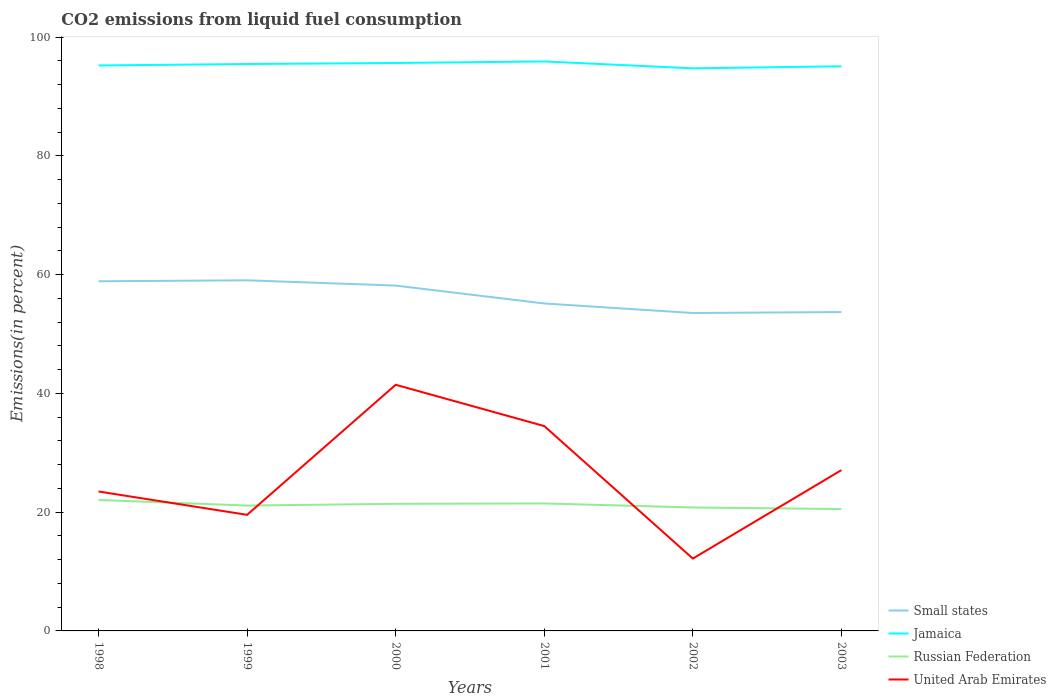How many different coloured lines are there?
Your response must be concise. 4. Does the line corresponding to United Arab Emirates intersect with the line corresponding to Small states?
Your answer should be very brief. No. Across all years, what is the maximum total CO2 emitted in United Arab Emirates?
Your answer should be very brief. 12.18. In which year was the total CO2 emitted in Russian Federation maximum?
Your response must be concise. 2003. What is the total total CO2 emitted in United Arab Emirates in the graph?
Offer a terse response. -14.95. What is the difference between the highest and the second highest total CO2 emitted in Small states?
Ensure brevity in your answer.  5.5. Is the total CO2 emitted in Small states strictly greater than the total CO2 emitted in Jamaica over the years?
Offer a very short reply. Yes. How many lines are there?
Provide a succinct answer. 4. How many years are there in the graph?
Provide a succinct answer. 6. What is the difference between two consecutive major ticks on the Y-axis?
Keep it short and to the point. 20. Does the graph contain any zero values?
Your response must be concise. No. Does the graph contain grids?
Make the answer very short. No. How many legend labels are there?
Offer a terse response. 4. What is the title of the graph?
Offer a terse response. CO2 emissions from liquid fuel consumption. Does "United Arab Emirates" appear as one of the legend labels in the graph?
Offer a very short reply. Yes. What is the label or title of the Y-axis?
Offer a terse response. Emissions(in percent). What is the Emissions(in percent) in Small states in 1998?
Make the answer very short. 58.88. What is the Emissions(in percent) of Jamaica in 1998?
Offer a very short reply. 95.21. What is the Emissions(in percent) of Russian Federation in 1998?
Offer a terse response. 22.05. What is the Emissions(in percent) of United Arab Emirates in 1998?
Make the answer very short. 23.48. What is the Emissions(in percent) of Small states in 1999?
Ensure brevity in your answer.  59.04. What is the Emissions(in percent) of Jamaica in 1999?
Offer a terse response. 95.46. What is the Emissions(in percent) in Russian Federation in 1999?
Make the answer very short. 21.11. What is the Emissions(in percent) of United Arab Emirates in 1999?
Provide a short and direct response. 19.55. What is the Emissions(in percent) of Small states in 2000?
Provide a short and direct response. 58.15. What is the Emissions(in percent) of Jamaica in 2000?
Make the answer very short. 95.63. What is the Emissions(in percent) of Russian Federation in 2000?
Offer a very short reply. 21.4. What is the Emissions(in percent) of United Arab Emirates in 2000?
Offer a terse response. 41.45. What is the Emissions(in percent) in Small states in 2001?
Your answer should be compact. 55.14. What is the Emissions(in percent) in Jamaica in 2001?
Your answer should be compact. 95.89. What is the Emissions(in percent) in Russian Federation in 2001?
Keep it short and to the point. 21.47. What is the Emissions(in percent) in United Arab Emirates in 2001?
Your answer should be very brief. 34.5. What is the Emissions(in percent) in Small states in 2002?
Provide a short and direct response. 53.53. What is the Emissions(in percent) in Jamaica in 2002?
Your answer should be compact. 94.73. What is the Emissions(in percent) in Russian Federation in 2002?
Provide a short and direct response. 20.79. What is the Emissions(in percent) in United Arab Emirates in 2002?
Keep it short and to the point. 12.18. What is the Emissions(in percent) in Small states in 2003?
Make the answer very short. 53.69. What is the Emissions(in percent) in Jamaica in 2003?
Ensure brevity in your answer.  95.08. What is the Emissions(in percent) of Russian Federation in 2003?
Offer a very short reply. 20.52. What is the Emissions(in percent) in United Arab Emirates in 2003?
Your response must be concise. 27.08. Across all years, what is the maximum Emissions(in percent) in Small states?
Make the answer very short. 59.04. Across all years, what is the maximum Emissions(in percent) in Jamaica?
Your response must be concise. 95.89. Across all years, what is the maximum Emissions(in percent) in Russian Federation?
Make the answer very short. 22.05. Across all years, what is the maximum Emissions(in percent) of United Arab Emirates?
Ensure brevity in your answer.  41.45. Across all years, what is the minimum Emissions(in percent) of Small states?
Provide a succinct answer. 53.53. Across all years, what is the minimum Emissions(in percent) of Jamaica?
Ensure brevity in your answer.  94.73. Across all years, what is the minimum Emissions(in percent) of Russian Federation?
Make the answer very short. 20.52. Across all years, what is the minimum Emissions(in percent) in United Arab Emirates?
Offer a very short reply. 12.18. What is the total Emissions(in percent) of Small states in the graph?
Your response must be concise. 338.43. What is the total Emissions(in percent) in Jamaica in the graph?
Give a very brief answer. 572. What is the total Emissions(in percent) in Russian Federation in the graph?
Offer a terse response. 127.34. What is the total Emissions(in percent) in United Arab Emirates in the graph?
Keep it short and to the point. 158.23. What is the difference between the Emissions(in percent) in Small states in 1998 and that in 1999?
Offer a terse response. -0.16. What is the difference between the Emissions(in percent) in Jamaica in 1998 and that in 1999?
Provide a short and direct response. -0.25. What is the difference between the Emissions(in percent) in Russian Federation in 1998 and that in 1999?
Your answer should be very brief. 0.94. What is the difference between the Emissions(in percent) of United Arab Emirates in 1998 and that in 1999?
Offer a very short reply. 3.93. What is the difference between the Emissions(in percent) of Small states in 1998 and that in 2000?
Make the answer very short. 0.73. What is the difference between the Emissions(in percent) of Jamaica in 1998 and that in 2000?
Provide a succinct answer. -0.42. What is the difference between the Emissions(in percent) of Russian Federation in 1998 and that in 2000?
Keep it short and to the point. 0.65. What is the difference between the Emissions(in percent) of United Arab Emirates in 1998 and that in 2000?
Your answer should be compact. -17.97. What is the difference between the Emissions(in percent) of Small states in 1998 and that in 2001?
Provide a succinct answer. 3.74. What is the difference between the Emissions(in percent) in Jamaica in 1998 and that in 2001?
Your answer should be very brief. -0.68. What is the difference between the Emissions(in percent) in Russian Federation in 1998 and that in 2001?
Make the answer very short. 0.58. What is the difference between the Emissions(in percent) of United Arab Emirates in 1998 and that in 2001?
Give a very brief answer. -11.02. What is the difference between the Emissions(in percent) of Small states in 1998 and that in 2002?
Provide a short and direct response. 5.34. What is the difference between the Emissions(in percent) of Jamaica in 1998 and that in 2002?
Ensure brevity in your answer.  0.48. What is the difference between the Emissions(in percent) in Russian Federation in 1998 and that in 2002?
Your response must be concise. 1.26. What is the difference between the Emissions(in percent) of United Arab Emirates in 1998 and that in 2002?
Provide a short and direct response. 11.3. What is the difference between the Emissions(in percent) in Small states in 1998 and that in 2003?
Your answer should be very brief. 5.18. What is the difference between the Emissions(in percent) in Jamaica in 1998 and that in 2003?
Your answer should be compact. 0.14. What is the difference between the Emissions(in percent) of Russian Federation in 1998 and that in 2003?
Give a very brief answer. 1.53. What is the difference between the Emissions(in percent) of United Arab Emirates in 1998 and that in 2003?
Provide a short and direct response. -3.6. What is the difference between the Emissions(in percent) in Small states in 1999 and that in 2000?
Provide a succinct answer. 0.89. What is the difference between the Emissions(in percent) in Jamaica in 1999 and that in 2000?
Your answer should be compact. -0.17. What is the difference between the Emissions(in percent) of Russian Federation in 1999 and that in 2000?
Offer a terse response. -0.3. What is the difference between the Emissions(in percent) in United Arab Emirates in 1999 and that in 2000?
Keep it short and to the point. -21.9. What is the difference between the Emissions(in percent) of Small states in 1999 and that in 2001?
Give a very brief answer. 3.9. What is the difference between the Emissions(in percent) in Jamaica in 1999 and that in 2001?
Keep it short and to the point. -0.43. What is the difference between the Emissions(in percent) in Russian Federation in 1999 and that in 2001?
Offer a terse response. -0.36. What is the difference between the Emissions(in percent) in United Arab Emirates in 1999 and that in 2001?
Provide a short and direct response. -14.95. What is the difference between the Emissions(in percent) of Small states in 1999 and that in 2002?
Offer a very short reply. 5.5. What is the difference between the Emissions(in percent) in Jamaica in 1999 and that in 2002?
Offer a very short reply. 0.73. What is the difference between the Emissions(in percent) in Russian Federation in 1999 and that in 2002?
Your answer should be compact. 0.32. What is the difference between the Emissions(in percent) in United Arab Emirates in 1999 and that in 2002?
Provide a succinct answer. 7.37. What is the difference between the Emissions(in percent) of Small states in 1999 and that in 2003?
Your response must be concise. 5.35. What is the difference between the Emissions(in percent) in Jamaica in 1999 and that in 2003?
Give a very brief answer. 0.38. What is the difference between the Emissions(in percent) in Russian Federation in 1999 and that in 2003?
Your answer should be compact. 0.59. What is the difference between the Emissions(in percent) of United Arab Emirates in 1999 and that in 2003?
Provide a succinct answer. -7.53. What is the difference between the Emissions(in percent) of Small states in 2000 and that in 2001?
Your answer should be compact. 3.01. What is the difference between the Emissions(in percent) in Jamaica in 2000 and that in 2001?
Ensure brevity in your answer.  -0.26. What is the difference between the Emissions(in percent) in Russian Federation in 2000 and that in 2001?
Give a very brief answer. -0.07. What is the difference between the Emissions(in percent) in United Arab Emirates in 2000 and that in 2001?
Offer a terse response. 6.95. What is the difference between the Emissions(in percent) in Small states in 2000 and that in 2002?
Keep it short and to the point. 4.62. What is the difference between the Emissions(in percent) in Jamaica in 2000 and that in 2002?
Offer a terse response. 0.9. What is the difference between the Emissions(in percent) in Russian Federation in 2000 and that in 2002?
Your answer should be very brief. 0.62. What is the difference between the Emissions(in percent) in United Arab Emirates in 2000 and that in 2002?
Keep it short and to the point. 29.27. What is the difference between the Emissions(in percent) of Small states in 2000 and that in 2003?
Keep it short and to the point. 4.46. What is the difference between the Emissions(in percent) in Jamaica in 2000 and that in 2003?
Your response must be concise. 0.55. What is the difference between the Emissions(in percent) of Russian Federation in 2000 and that in 2003?
Make the answer very short. 0.88. What is the difference between the Emissions(in percent) in United Arab Emirates in 2000 and that in 2003?
Offer a terse response. 14.37. What is the difference between the Emissions(in percent) of Small states in 2001 and that in 2002?
Make the answer very short. 1.61. What is the difference between the Emissions(in percent) in Jamaica in 2001 and that in 2002?
Give a very brief answer. 1.16. What is the difference between the Emissions(in percent) in Russian Federation in 2001 and that in 2002?
Offer a very short reply. 0.68. What is the difference between the Emissions(in percent) in United Arab Emirates in 2001 and that in 2002?
Offer a very short reply. 22.31. What is the difference between the Emissions(in percent) in Small states in 2001 and that in 2003?
Make the answer very short. 1.45. What is the difference between the Emissions(in percent) of Jamaica in 2001 and that in 2003?
Offer a very short reply. 0.82. What is the difference between the Emissions(in percent) of Russian Federation in 2001 and that in 2003?
Your response must be concise. 0.95. What is the difference between the Emissions(in percent) in United Arab Emirates in 2001 and that in 2003?
Your answer should be very brief. 7.42. What is the difference between the Emissions(in percent) in Small states in 2002 and that in 2003?
Offer a terse response. -0.16. What is the difference between the Emissions(in percent) of Jamaica in 2002 and that in 2003?
Provide a succinct answer. -0.34. What is the difference between the Emissions(in percent) in Russian Federation in 2002 and that in 2003?
Offer a very short reply. 0.27. What is the difference between the Emissions(in percent) in United Arab Emirates in 2002 and that in 2003?
Offer a very short reply. -14.89. What is the difference between the Emissions(in percent) of Small states in 1998 and the Emissions(in percent) of Jamaica in 1999?
Give a very brief answer. -36.58. What is the difference between the Emissions(in percent) of Small states in 1998 and the Emissions(in percent) of Russian Federation in 1999?
Keep it short and to the point. 37.77. What is the difference between the Emissions(in percent) of Small states in 1998 and the Emissions(in percent) of United Arab Emirates in 1999?
Keep it short and to the point. 39.33. What is the difference between the Emissions(in percent) in Jamaica in 1998 and the Emissions(in percent) in Russian Federation in 1999?
Make the answer very short. 74.1. What is the difference between the Emissions(in percent) of Jamaica in 1998 and the Emissions(in percent) of United Arab Emirates in 1999?
Ensure brevity in your answer.  75.66. What is the difference between the Emissions(in percent) of Russian Federation in 1998 and the Emissions(in percent) of United Arab Emirates in 1999?
Give a very brief answer. 2.5. What is the difference between the Emissions(in percent) of Small states in 1998 and the Emissions(in percent) of Jamaica in 2000?
Give a very brief answer. -36.75. What is the difference between the Emissions(in percent) in Small states in 1998 and the Emissions(in percent) in Russian Federation in 2000?
Offer a terse response. 37.47. What is the difference between the Emissions(in percent) in Small states in 1998 and the Emissions(in percent) in United Arab Emirates in 2000?
Your answer should be compact. 17.43. What is the difference between the Emissions(in percent) of Jamaica in 1998 and the Emissions(in percent) of Russian Federation in 2000?
Provide a short and direct response. 73.81. What is the difference between the Emissions(in percent) of Jamaica in 1998 and the Emissions(in percent) of United Arab Emirates in 2000?
Provide a succinct answer. 53.76. What is the difference between the Emissions(in percent) of Russian Federation in 1998 and the Emissions(in percent) of United Arab Emirates in 2000?
Ensure brevity in your answer.  -19.4. What is the difference between the Emissions(in percent) of Small states in 1998 and the Emissions(in percent) of Jamaica in 2001?
Ensure brevity in your answer.  -37.02. What is the difference between the Emissions(in percent) in Small states in 1998 and the Emissions(in percent) in Russian Federation in 2001?
Your answer should be compact. 37.41. What is the difference between the Emissions(in percent) in Small states in 1998 and the Emissions(in percent) in United Arab Emirates in 2001?
Offer a very short reply. 24.38. What is the difference between the Emissions(in percent) in Jamaica in 1998 and the Emissions(in percent) in Russian Federation in 2001?
Your answer should be compact. 73.74. What is the difference between the Emissions(in percent) in Jamaica in 1998 and the Emissions(in percent) in United Arab Emirates in 2001?
Keep it short and to the point. 60.72. What is the difference between the Emissions(in percent) in Russian Federation in 1998 and the Emissions(in percent) in United Arab Emirates in 2001?
Your answer should be compact. -12.45. What is the difference between the Emissions(in percent) of Small states in 1998 and the Emissions(in percent) of Jamaica in 2002?
Your answer should be compact. -35.85. What is the difference between the Emissions(in percent) in Small states in 1998 and the Emissions(in percent) in Russian Federation in 2002?
Offer a very short reply. 38.09. What is the difference between the Emissions(in percent) of Small states in 1998 and the Emissions(in percent) of United Arab Emirates in 2002?
Give a very brief answer. 46.7. What is the difference between the Emissions(in percent) in Jamaica in 1998 and the Emissions(in percent) in Russian Federation in 2002?
Provide a succinct answer. 74.43. What is the difference between the Emissions(in percent) in Jamaica in 1998 and the Emissions(in percent) in United Arab Emirates in 2002?
Make the answer very short. 83.03. What is the difference between the Emissions(in percent) of Russian Federation in 1998 and the Emissions(in percent) of United Arab Emirates in 2002?
Your answer should be very brief. 9.87. What is the difference between the Emissions(in percent) of Small states in 1998 and the Emissions(in percent) of Jamaica in 2003?
Offer a terse response. -36.2. What is the difference between the Emissions(in percent) in Small states in 1998 and the Emissions(in percent) in Russian Federation in 2003?
Keep it short and to the point. 38.36. What is the difference between the Emissions(in percent) in Small states in 1998 and the Emissions(in percent) in United Arab Emirates in 2003?
Your response must be concise. 31.8. What is the difference between the Emissions(in percent) in Jamaica in 1998 and the Emissions(in percent) in Russian Federation in 2003?
Offer a terse response. 74.69. What is the difference between the Emissions(in percent) in Jamaica in 1998 and the Emissions(in percent) in United Arab Emirates in 2003?
Your answer should be very brief. 68.14. What is the difference between the Emissions(in percent) in Russian Federation in 1998 and the Emissions(in percent) in United Arab Emirates in 2003?
Provide a short and direct response. -5.03. What is the difference between the Emissions(in percent) in Small states in 1999 and the Emissions(in percent) in Jamaica in 2000?
Your response must be concise. -36.59. What is the difference between the Emissions(in percent) in Small states in 1999 and the Emissions(in percent) in Russian Federation in 2000?
Your answer should be compact. 37.63. What is the difference between the Emissions(in percent) in Small states in 1999 and the Emissions(in percent) in United Arab Emirates in 2000?
Your answer should be compact. 17.59. What is the difference between the Emissions(in percent) of Jamaica in 1999 and the Emissions(in percent) of Russian Federation in 2000?
Your answer should be compact. 74.06. What is the difference between the Emissions(in percent) in Jamaica in 1999 and the Emissions(in percent) in United Arab Emirates in 2000?
Offer a terse response. 54.01. What is the difference between the Emissions(in percent) of Russian Federation in 1999 and the Emissions(in percent) of United Arab Emirates in 2000?
Make the answer very short. -20.34. What is the difference between the Emissions(in percent) in Small states in 1999 and the Emissions(in percent) in Jamaica in 2001?
Provide a succinct answer. -36.86. What is the difference between the Emissions(in percent) in Small states in 1999 and the Emissions(in percent) in Russian Federation in 2001?
Offer a very short reply. 37.57. What is the difference between the Emissions(in percent) of Small states in 1999 and the Emissions(in percent) of United Arab Emirates in 2001?
Provide a succinct answer. 24.54. What is the difference between the Emissions(in percent) of Jamaica in 1999 and the Emissions(in percent) of Russian Federation in 2001?
Give a very brief answer. 73.99. What is the difference between the Emissions(in percent) of Jamaica in 1999 and the Emissions(in percent) of United Arab Emirates in 2001?
Your answer should be compact. 60.96. What is the difference between the Emissions(in percent) in Russian Federation in 1999 and the Emissions(in percent) in United Arab Emirates in 2001?
Give a very brief answer. -13.39. What is the difference between the Emissions(in percent) in Small states in 1999 and the Emissions(in percent) in Jamaica in 2002?
Offer a very short reply. -35.69. What is the difference between the Emissions(in percent) in Small states in 1999 and the Emissions(in percent) in Russian Federation in 2002?
Make the answer very short. 38.25. What is the difference between the Emissions(in percent) of Small states in 1999 and the Emissions(in percent) of United Arab Emirates in 2002?
Make the answer very short. 46.86. What is the difference between the Emissions(in percent) of Jamaica in 1999 and the Emissions(in percent) of Russian Federation in 2002?
Your response must be concise. 74.67. What is the difference between the Emissions(in percent) of Jamaica in 1999 and the Emissions(in percent) of United Arab Emirates in 2002?
Offer a very short reply. 83.28. What is the difference between the Emissions(in percent) of Russian Federation in 1999 and the Emissions(in percent) of United Arab Emirates in 2002?
Make the answer very short. 8.93. What is the difference between the Emissions(in percent) in Small states in 1999 and the Emissions(in percent) in Jamaica in 2003?
Make the answer very short. -36.04. What is the difference between the Emissions(in percent) of Small states in 1999 and the Emissions(in percent) of Russian Federation in 2003?
Offer a very short reply. 38.52. What is the difference between the Emissions(in percent) of Small states in 1999 and the Emissions(in percent) of United Arab Emirates in 2003?
Offer a terse response. 31.96. What is the difference between the Emissions(in percent) of Jamaica in 1999 and the Emissions(in percent) of Russian Federation in 2003?
Keep it short and to the point. 74.94. What is the difference between the Emissions(in percent) in Jamaica in 1999 and the Emissions(in percent) in United Arab Emirates in 2003?
Offer a terse response. 68.38. What is the difference between the Emissions(in percent) of Russian Federation in 1999 and the Emissions(in percent) of United Arab Emirates in 2003?
Keep it short and to the point. -5.97. What is the difference between the Emissions(in percent) in Small states in 2000 and the Emissions(in percent) in Jamaica in 2001?
Provide a short and direct response. -37.74. What is the difference between the Emissions(in percent) of Small states in 2000 and the Emissions(in percent) of Russian Federation in 2001?
Provide a short and direct response. 36.68. What is the difference between the Emissions(in percent) in Small states in 2000 and the Emissions(in percent) in United Arab Emirates in 2001?
Your answer should be very brief. 23.66. What is the difference between the Emissions(in percent) in Jamaica in 2000 and the Emissions(in percent) in Russian Federation in 2001?
Keep it short and to the point. 74.16. What is the difference between the Emissions(in percent) in Jamaica in 2000 and the Emissions(in percent) in United Arab Emirates in 2001?
Your response must be concise. 61.13. What is the difference between the Emissions(in percent) in Russian Federation in 2000 and the Emissions(in percent) in United Arab Emirates in 2001?
Keep it short and to the point. -13.09. What is the difference between the Emissions(in percent) of Small states in 2000 and the Emissions(in percent) of Jamaica in 2002?
Provide a short and direct response. -36.58. What is the difference between the Emissions(in percent) of Small states in 2000 and the Emissions(in percent) of Russian Federation in 2002?
Provide a succinct answer. 37.36. What is the difference between the Emissions(in percent) of Small states in 2000 and the Emissions(in percent) of United Arab Emirates in 2002?
Provide a succinct answer. 45.97. What is the difference between the Emissions(in percent) of Jamaica in 2000 and the Emissions(in percent) of Russian Federation in 2002?
Your response must be concise. 74.84. What is the difference between the Emissions(in percent) of Jamaica in 2000 and the Emissions(in percent) of United Arab Emirates in 2002?
Provide a succinct answer. 83.45. What is the difference between the Emissions(in percent) in Russian Federation in 2000 and the Emissions(in percent) in United Arab Emirates in 2002?
Provide a short and direct response. 9.22. What is the difference between the Emissions(in percent) of Small states in 2000 and the Emissions(in percent) of Jamaica in 2003?
Your answer should be very brief. -36.92. What is the difference between the Emissions(in percent) in Small states in 2000 and the Emissions(in percent) in Russian Federation in 2003?
Ensure brevity in your answer.  37.63. What is the difference between the Emissions(in percent) in Small states in 2000 and the Emissions(in percent) in United Arab Emirates in 2003?
Your response must be concise. 31.07. What is the difference between the Emissions(in percent) in Jamaica in 2000 and the Emissions(in percent) in Russian Federation in 2003?
Make the answer very short. 75.11. What is the difference between the Emissions(in percent) in Jamaica in 2000 and the Emissions(in percent) in United Arab Emirates in 2003?
Offer a terse response. 68.55. What is the difference between the Emissions(in percent) in Russian Federation in 2000 and the Emissions(in percent) in United Arab Emirates in 2003?
Make the answer very short. -5.67. What is the difference between the Emissions(in percent) in Small states in 2001 and the Emissions(in percent) in Jamaica in 2002?
Keep it short and to the point. -39.59. What is the difference between the Emissions(in percent) in Small states in 2001 and the Emissions(in percent) in Russian Federation in 2002?
Your answer should be very brief. 34.35. What is the difference between the Emissions(in percent) in Small states in 2001 and the Emissions(in percent) in United Arab Emirates in 2002?
Make the answer very short. 42.96. What is the difference between the Emissions(in percent) in Jamaica in 2001 and the Emissions(in percent) in Russian Federation in 2002?
Provide a short and direct response. 75.11. What is the difference between the Emissions(in percent) in Jamaica in 2001 and the Emissions(in percent) in United Arab Emirates in 2002?
Your answer should be very brief. 83.71. What is the difference between the Emissions(in percent) of Russian Federation in 2001 and the Emissions(in percent) of United Arab Emirates in 2002?
Your answer should be very brief. 9.29. What is the difference between the Emissions(in percent) of Small states in 2001 and the Emissions(in percent) of Jamaica in 2003?
Provide a succinct answer. -39.94. What is the difference between the Emissions(in percent) of Small states in 2001 and the Emissions(in percent) of Russian Federation in 2003?
Offer a terse response. 34.62. What is the difference between the Emissions(in percent) in Small states in 2001 and the Emissions(in percent) in United Arab Emirates in 2003?
Give a very brief answer. 28.06. What is the difference between the Emissions(in percent) in Jamaica in 2001 and the Emissions(in percent) in Russian Federation in 2003?
Keep it short and to the point. 75.37. What is the difference between the Emissions(in percent) in Jamaica in 2001 and the Emissions(in percent) in United Arab Emirates in 2003?
Keep it short and to the point. 68.82. What is the difference between the Emissions(in percent) in Russian Federation in 2001 and the Emissions(in percent) in United Arab Emirates in 2003?
Make the answer very short. -5.61. What is the difference between the Emissions(in percent) in Small states in 2002 and the Emissions(in percent) in Jamaica in 2003?
Make the answer very short. -41.54. What is the difference between the Emissions(in percent) of Small states in 2002 and the Emissions(in percent) of Russian Federation in 2003?
Your response must be concise. 33.01. What is the difference between the Emissions(in percent) in Small states in 2002 and the Emissions(in percent) in United Arab Emirates in 2003?
Your answer should be very brief. 26.46. What is the difference between the Emissions(in percent) of Jamaica in 2002 and the Emissions(in percent) of Russian Federation in 2003?
Make the answer very short. 74.21. What is the difference between the Emissions(in percent) in Jamaica in 2002 and the Emissions(in percent) in United Arab Emirates in 2003?
Offer a very short reply. 67.65. What is the difference between the Emissions(in percent) in Russian Federation in 2002 and the Emissions(in percent) in United Arab Emirates in 2003?
Keep it short and to the point. -6.29. What is the average Emissions(in percent) of Small states per year?
Your answer should be compact. 56.41. What is the average Emissions(in percent) of Jamaica per year?
Your answer should be very brief. 95.33. What is the average Emissions(in percent) of Russian Federation per year?
Provide a short and direct response. 21.22. What is the average Emissions(in percent) of United Arab Emirates per year?
Offer a terse response. 26.37. In the year 1998, what is the difference between the Emissions(in percent) of Small states and Emissions(in percent) of Jamaica?
Provide a short and direct response. -36.33. In the year 1998, what is the difference between the Emissions(in percent) in Small states and Emissions(in percent) in Russian Federation?
Make the answer very short. 36.83. In the year 1998, what is the difference between the Emissions(in percent) in Small states and Emissions(in percent) in United Arab Emirates?
Keep it short and to the point. 35.4. In the year 1998, what is the difference between the Emissions(in percent) of Jamaica and Emissions(in percent) of Russian Federation?
Offer a terse response. 73.16. In the year 1998, what is the difference between the Emissions(in percent) of Jamaica and Emissions(in percent) of United Arab Emirates?
Keep it short and to the point. 71.73. In the year 1998, what is the difference between the Emissions(in percent) in Russian Federation and Emissions(in percent) in United Arab Emirates?
Make the answer very short. -1.43. In the year 1999, what is the difference between the Emissions(in percent) of Small states and Emissions(in percent) of Jamaica?
Give a very brief answer. -36.42. In the year 1999, what is the difference between the Emissions(in percent) of Small states and Emissions(in percent) of Russian Federation?
Keep it short and to the point. 37.93. In the year 1999, what is the difference between the Emissions(in percent) in Small states and Emissions(in percent) in United Arab Emirates?
Make the answer very short. 39.49. In the year 1999, what is the difference between the Emissions(in percent) in Jamaica and Emissions(in percent) in Russian Federation?
Provide a short and direct response. 74.35. In the year 1999, what is the difference between the Emissions(in percent) of Jamaica and Emissions(in percent) of United Arab Emirates?
Make the answer very short. 75.91. In the year 1999, what is the difference between the Emissions(in percent) of Russian Federation and Emissions(in percent) of United Arab Emirates?
Offer a terse response. 1.56. In the year 2000, what is the difference between the Emissions(in percent) in Small states and Emissions(in percent) in Jamaica?
Ensure brevity in your answer.  -37.48. In the year 2000, what is the difference between the Emissions(in percent) in Small states and Emissions(in percent) in Russian Federation?
Ensure brevity in your answer.  36.75. In the year 2000, what is the difference between the Emissions(in percent) of Small states and Emissions(in percent) of United Arab Emirates?
Make the answer very short. 16.7. In the year 2000, what is the difference between the Emissions(in percent) of Jamaica and Emissions(in percent) of Russian Federation?
Make the answer very short. 74.23. In the year 2000, what is the difference between the Emissions(in percent) in Jamaica and Emissions(in percent) in United Arab Emirates?
Provide a short and direct response. 54.18. In the year 2000, what is the difference between the Emissions(in percent) of Russian Federation and Emissions(in percent) of United Arab Emirates?
Offer a terse response. -20.04. In the year 2001, what is the difference between the Emissions(in percent) in Small states and Emissions(in percent) in Jamaica?
Your response must be concise. -40.75. In the year 2001, what is the difference between the Emissions(in percent) in Small states and Emissions(in percent) in Russian Federation?
Provide a short and direct response. 33.67. In the year 2001, what is the difference between the Emissions(in percent) of Small states and Emissions(in percent) of United Arab Emirates?
Make the answer very short. 20.64. In the year 2001, what is the difference between the Emissions(in percent) of Jamaica and Emissions(in percent) of Russian Federation?
Provide a short and direct response. 74.42. In the year 2001, what is the difference between the Emissions(in percent) of Jamaica and Emissions(in percent) of United Arab Emirates?
Provide a succinct answer. 61.4. In the year 2001, what is the difference between the Emissions(in percent) of Russian Federation and Emissions(in percent) of United Arab Emirates?
Make the answer very short. -13.02. In the year 2002, what is the difference between the Emissions(in percent) in Small states and Emissions(in percent) in Jamaica?
Your response must be concise. -41.2. In the year 2002, what is the difference between the Emissions(in percent) of Small states and Emissions(in percent) of Russian Federation?
Make the answer very short. 32.75. In the year 2002, what is the difference between the Emissions(in percent) of Small states and Emissions(in percent) of United Arab Emirates?
Ensure brevity in your answer.  41.35. In the year 2002, what is the difference between the Emissions(in percent) in Jamaica and Emissions(in percent) in Russian Federation?
Provide a short and direct response. 73.94. In the year 2002, what is the difference between the Emissions(in percent) in Jamaica and Emissions(in percent) in United Arab Emirates?
Make the answer very short. 82.55. In the year 2002, what is the difference between the Emissions(in percent) of Russian Federation and Emissions(in percent) of United Arab Emirates?
Offer a very short reply. 8.61. In the year 2003, what is the difference between the Emissions(in percent) in Small states and Emissions(in percent) in Jamaica?
Your answer should be very brief. -41.38. In the year 2003, what is the difference between the Emissions(in percent) in Small states and Emissions(in percent) in Russian Federation?
Offer a very short reply. 33.17. In the year 2003, what is the difference between the Emissions(in percent) of Small states and Emissions(in percent) of United Arab Emirates?
Offer a very short reply. 26.62. In the year 2003, what is the difference between the Emissions(in percent) of Jamaica and Emissions(in percent) of Russian Federation?
Your answer should be very brief. 74.55. In the year 2003, what is the difference between the Emissions(in percent) in Jamaica and Emissions(in percent) in United Arab Emirates?
Offer a terse response. 68. In the year 2003, what is the difference between the Emissions(in percent) of Russian Federation and Emissions(in percent) of United Arab Emirates?
Your response must be concise. -6.56. What is the ratio of the Emissions(in percent) in Small states in 1998 to that in 1999?
Offer a very short reply. 1. What is the ratio of the Emissions(in percent) of Jamaica in 1998 to that in 1999?
Give a very brief answer. 1. What is the ratio of the Emissions(in percent) in Russian Federation in 1998 to that in 1999?
Your answer should be compact. 1.04. What is the ratio of the Emissions(in percent) of United Arab Emirates in 1998 to that in 1999?
Provide a succinct answer. 1.2. What is the ratio of the Emissions(in percent) in Small states in 1998 to that in 2000?
Your answer should be compact. 1.01. What is the ratio of the Emissions(in percent) in Jamaica in 1998 to that in 2000?
Give a very brief answer. 1. What is the ratio of the Emissions(in percent) in Russian Federation in 1998 to that in 2000?
Your answer should be compact. 1.03. What is the ratio of the Emissions(in percent) in United Arab Emirates in 1998 to that in 2000?
Give a very brief answer. 0.57. What is the ratio of the Emissions(in percent) of Small states in 1998 to that in 2001?
Offer a terse response. 1.07. What is the ratio of the Emissions(in percent) of United Arab Emirates in 1998 to that in 2001?
Offer a very short reply. 0.68. What is the ratio of the Emissions(in percent) of Small states in 1998 to that in 2002?
Offer a very short reply. 1.1. What is the ratio of the Emissions(in percent) in Russian Federation in 1998 to that in 2002?
Your answer should be compact. 1.06. What is the ratio of the Emissions(in percent) in United Arab Emirates in 1998 to that in 2002?
Your response must be concise. 1.93. What is the ratio of the Emissions(in percent) in Small states in 1998 to that in 2003?
Provide a succinct answer. 1.1. What is the ratio of the Emissions(in percent) of Jamaica in 1998 to that in 2003?
Your response must be concise. 1. What is the ratio of the Emissions(in percent) of Russian Federation in 1998 to that in 2003?
Offer a terse response. 1.07. What is the ratio of the Emissions(in percent) of United Arab Emirates in 1998 to that in 2003?
Keep it short and to the point. 0.87. What is the ratio of the Emissions(in percent) in Small states in 1999 to that in 2000?
Your response must be concise. 1.02. What is the ratio of the Emissions(in percent) in Russian Federation in 1999 to that in 2000?
Make the answer very short. 0.99. What is the ratio of the Emissions(in percent) of United Arab Emirates in 1999 to that in 2000?
Offer a terse response. 0.47. What is the ratio of the Emissions(in percent) of Small states in 1999 to that in 2001?
Provide a short and direct response. 1.07. What is the ratio of the Emissions(in percent) of Jamaica in 1999 to that in 2001?
Provide a succinct answer. 1. What is the ratio of the Emissions(in percent) of Russian Federation in 1999 to that in 2001?
Your answer should be compact. 0.98. What is the ratio of the Emissions(in percent) of United Arab Emirates in 1999 to that in 2001?
Provide a succinct answer. 0.57. What is the ratio of the Emissions(in percent) in Small states in 1999 to that in 2002?
Your response must be concise. 1.1. What is the ratio of the Emissions(in percent) in Jamaica in 1999 to that in 2002?
Provide a succinct answer. 1.01. What is the ratio of the Emissions(in percent) in Russian Federation in 1999 to that in 2002?
Your answer should be compact. 1.02. What is the ratio of the Emissions(in percent) of United Arab Emirates in 1999 to that in 2002?
Offer a terse response. 1.6. What is the ratio of the Emissions(in percent) in Small states in 1999 to that in 2003?
Your answer should be very brief. 1.1. What is the ratio of the Emissions(in percent) of Russian Federation in 1999 to that in 2003?
Offer a terse response. 1.03. What is the ratio of the Emissions(in percent) in United Arab Emirates in 1999 to that in 2003?
Offer a very short reply. 0.72. What is the ratio of the Emissions(in percent) of Small states in 2000 to that in 2001?
Provide a succinct answer. 1.05. What is the ratio of the Emissions(in percent) in Russian Federation in 2000 to that in 2001?
Offer a terse response. 1. What is the ratio of the Emissions(in percent) of United Arab Emirates in 2000 to that in 2001?
Your answer should be compact. 1.2. What is the ratio of the Emissions(in percent) of Small states in 2000 to that in 2002?
Offer a very short reply. 1.09. What is the ratio of the Emissions(in percent) of Jamaica in 2000 to that in 2002?
Give a very brief answer. 1.01. What is the ratio of the Emissions(in percent) of Russian Federation in 2000 to that in 2002?
Provide a short and direct response. 1.03. What is the ratio of the Emissions(in percent) in United Arab Emirates in 2000 to that in 2002?
Keep it short and to the point. 3.4. What is the ratio of the Emissions(in percent) in Small states in 2000 to that in 2003?
Offer a terse response. 1.08. What is the ratio of the Emissions(in percent) of Jamaica in 2000 to that in 2003?
Make the answer very short. 1.01. What is the ratio of the Emissions(in percent) of Russian Federation in 2000 to that in 2003?
Offer a very short reply. 1.04. What is the ratio of the Emissions(in percent) in United Arab Emirates in 2000 to that in 2003?
Your answer should be compact. 1.53. What is the ratio of the Emissions(in percent) in Jamaica in 2001 to that in 2002?
Keep it short and to the point. 1.01. What is the ratio of the Emissions(in percent) in Russian Federation in 2001 to that in 2002?
Offer a terse response. 1.03. What is the ratio of the Emissions(in percent) in United Arab Emirates in 2001 to that in 2002?
Make the answer very short. 2.83. What is the ratio of the Emissions(in percent) of Small states in 2001 to that in 2003?
Provide a short and direct response. 1.03. What is the ratio of the Emissions(in percent) of Jamaica in 2001 to that in 2003?
Keep it short and to the point. 1.01. What is the ratio of the Emissions(in percent) in Russian Federation in 2001 to that in 2003?
Your answer should be very brief. 1.05. What is the ratio of the Emissions(in percent) of United Arab Emirates in 2001 to that in 2003?
Your answer should be very brief. 1.27. What is the ratio of the Emissions(in percent) of Small states in 2002 to that in 2003?
Make the answer very short. 1. What is the ratio of the Emissions(in percent) of Jamaica in 2002 to that in 2003?
Give a very brief answer. 1. What is the ratio of the Emissions(in percent) of Russian Federation in 2002 to that in 2003?
Offer a terse response. 1.01. What is the ratio of the Emissions(in percent) in United Arab Emirates in 2002 to that in 2003?
Make the answer very short. 0.45. What is the difference between the highest and the second highest Emissions(in percent) in Small states?
Make the answer very short. 0.16. What is the difference between the highest and the second highest Emissions(in percent) of Jamaica?
Offer a terse response. 0.26. What is the difference between the highest and the second highest Emissions(in percent) of Russian Federation?
Your response must be concise. 0.58. What is the difference between the highest and the second highest Emissions(in percent) in United Arab Emirates?
Provide a short and direct response. 6.95. What is the difference between the highest and the lowest Emissions(in percent) in Small states?
Your response must be concise. 5.5. What is the difference between the highest and the lowest Emissions(in percent) in Jamaica?
Provide a succinct answer. 1.16. What is the difference between the highest and the lowest Emissions(in percent) in Russian Federation?
Ensure brevity in your answer.  1.53. What is the difference between the highest and the lowest Emissions(in percent) in United Arab Emirates?
Make the answer very short. 29.27. 